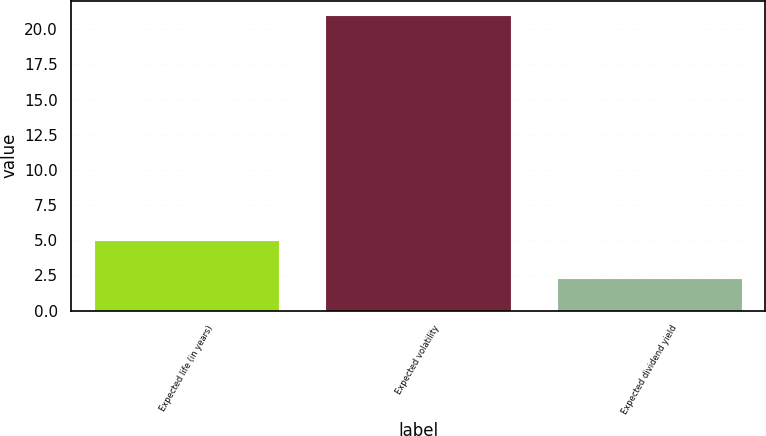<chart> <loc_0><loc_0><loc_500><loc_500><bar_chart><fcel>Expected life (in years)<fcel>Expected volatility<fcel>Expected dividend yield<nl><fcel>5<fcel>21<fcel>2.3<nl></chart> 